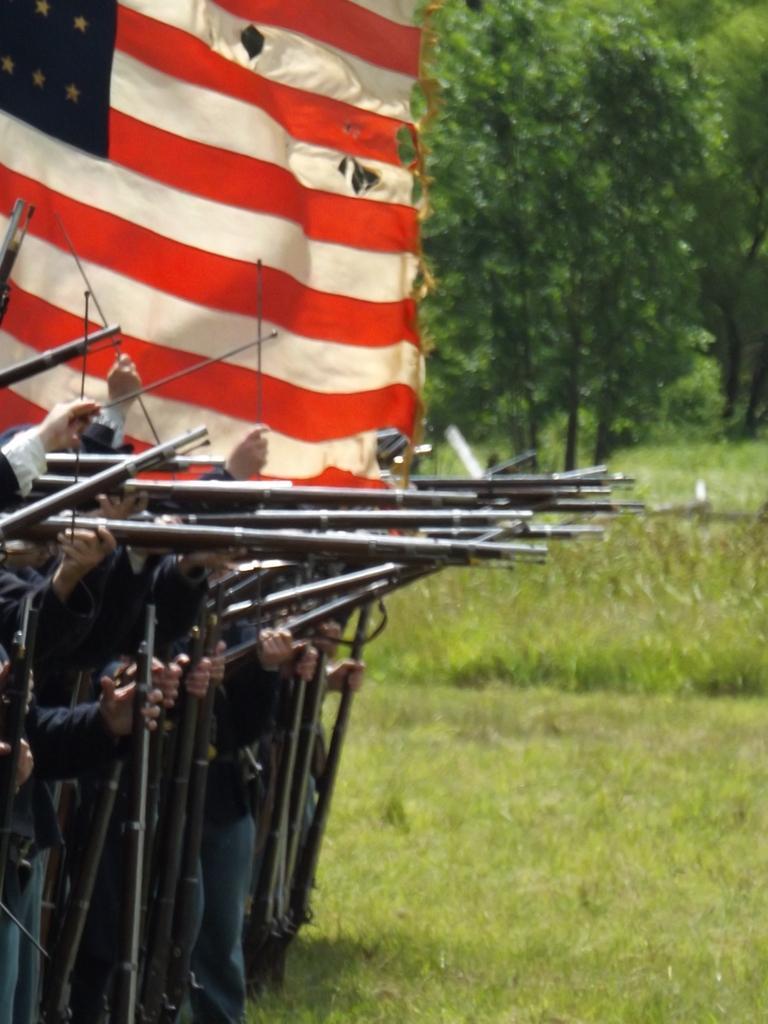How would you summarize this image in a sentence or two? On the left there are soldiers holding guns and there is a flag. In the background there are trees, shrubs and grass. 